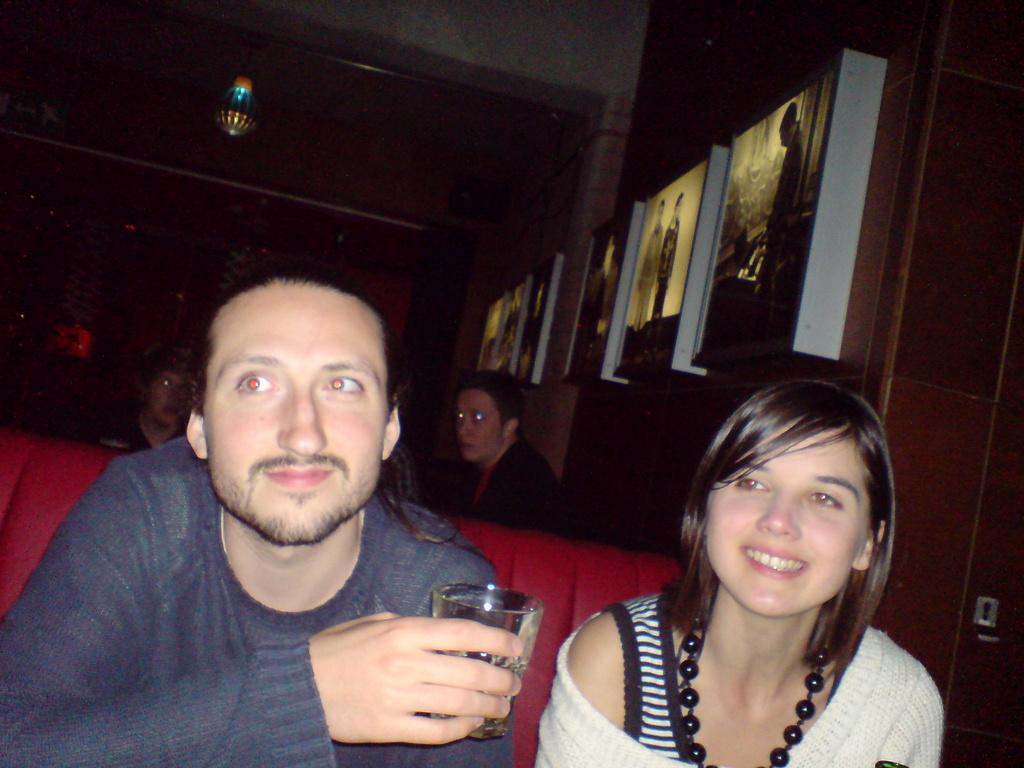Can you describe this image briefly? This picture shows few people seated and we see a man holding a glass in his hand and we see photo frames on the wall and a woman wore ornament. 